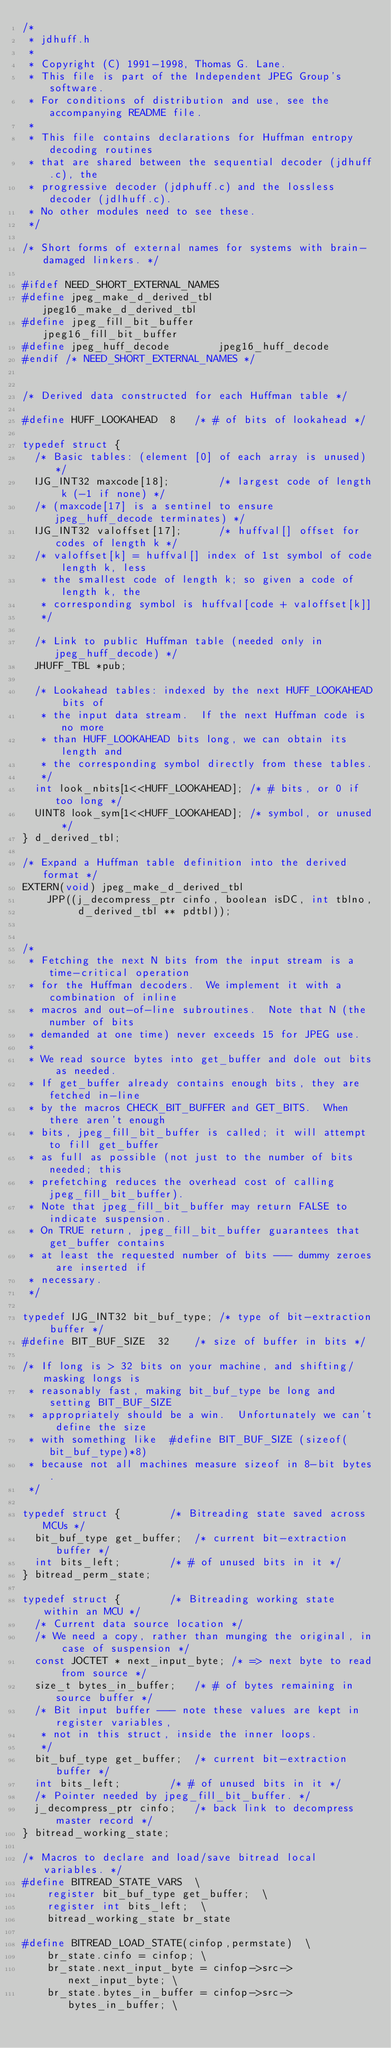<code> <loc_0><loc_0><loc_500><loc_500><_C_>/*
 * jdhuff.h
 *
 * Copyright (C) 1991-1998, Thomas G. Lane.
 * This file is part of the Independent JPEG Group's software.
 * For conditions of distribution and use, see the accompanying README file.
 *
 * This file contains declarations for Huffman entropy decoding routines
 * that are shared between the sequential decoder (jdhuff.c), the
 * progressive decoder (jdphuff.c) and the lossless decoder (jdlhuff.c).
 * No other modules need to see these.
 */

/* Short forms of external names for systems with brain-damaged linkers. */

#ifdef NEED_SHORT_EXTERNAL_NAMES
#define jpeg_make_d_derived_tbl		jpeg16_make_d_derived_tbl
#define jpeg_fill_bit_buffer		jpeg16_fill_bit_buffer
#define jpeg_huff_decode		jpeg16_huff_decode
#endif /* NEED_SHORT_EXTERNAL_NAMES */


/* Derived data constructed for each Huffman table */

#define HUFF_LOOKAHEAD	8	/* # of bits of lookahead */

typedef struct {
  /* Basic tables: (element [0] of each array is unused) */
  IJG_INT32 maxcode[18];		/* largest code of length k (-1 if none) */
  /* (maxcode[17] is a sentinel to ensure jpeg_huff_decode terminates) */
  IJG_INT32 valoffset[17];		/* huffval[] offset for codes of length k */
  /* valoffset[k] = huffval[] index of 1st symbol of code length k, less
   * the smallest code of length k; so given a code of length k, the
   * corresponding symbol is huffval[code + valoffset[k]]
   */

  /* Link to public Huffman table (needed only in jpeg_huff_decode) */
  JHUFF_TBL *pub;

  /* Lookahead tables: indexed by the next HUFF_LOOKAHEAD bits of
   * the input data stream.  If the next Huffman code is no more
   * than HUFF_LOOKAHEAD bits long, we can obtain its length and
   * the corresponding symbol directly from these tables.
   */
  int look_nbits[1<<HUFF_LOOKAHEAD]; /* # bits, or 0 if too long */
  UINT8 look_sym[1<<HUFF_LOOKAHEAD]; /* symbol, or unused */
} d_derived_tbl;

/* Expand a Huffman table definition into the derived format */
EXTERN(void) jpeg_make_d_derived_tbl
	JPP((j_decompress_ptr cinfo, boolean isDC, int tblno,
	     d_derived_tbl ** pdtbl));


/*
 * Fetching the next N bits from the input stream is a time-critical operation
 * for the Huffman decoders.  We implement it with a combination of inline
 * macros and out-of-line subroutines.  Note that N (the number of bits
 * demanded at one time) never exceeds 15 for JPEG use.
 *
 * We read source bytes into get_buffer and dole out bits as needed.
 * If get_buffer already contains enough bits, they are fetched in-line
 * by the macros CHECK_BIT_BUFFER and GET_BITS.  When there aren't enough
 * bits, jpeg_fill_bit_buffer is called; it will attempt to fill get_buffer
 * as full as possible (not just to the number of bits needed; this
 * prefetching reduces the overhead cost of calling jpeg_fill_bit_buffer).
 * Note that jpeg_fill_bit_buffer may return FALSE to indicate suspension.
 * On TRUE return, jpeg_fill_bit_buffer guarantees that get_buffer contains
 * at least the requested number of bits --- dummy zeroes are inserted if
 * necessary.
 */

typedef IJG_INT32 bit_buf_type;	/* type of bit-extraction buffer */
#define BIT_BUF_SIZE  32	/* size of buffer in bits */

/* If long is > 32 bits on your machine, and shifting/masking longs is
 * reasonably fast, making bit_buf_type be long and setting BIT_BUF_SIZE
 * appropriately should be a win.  Unfortunately we can't define the size
 * with something like  #define BIT_BUF_SIZE (sizeof(bit_buf_type)*8)
 * because not all machines measure sizeof in 8-bit bytes.
 */

typedef struct {		/* Bitreading state saved across MCUs */
  bit_buf_type get_buffer;	/* current bit-extraction buffer */
  int bits_left;		/* # of unused bits in it */
} bitread_perm_state;

typedef struct {		/* Bitreading working state within an MCU */
  /* Current data source location */
  /* We need a copy, rather than munging the original, in case of suspension */
  const JOCTET * next_input_byte; /* => next byte to read from source */
  size_t bytes_in_buffer;	/* # of bytes remaining in source buffer */
  /* Bit input buffer --- note these values are kept in register variables,
   * not in this struct, inside the inner loops.
   */
  bit_buf_type get_buffer;	/* current bit-extraction buffer */
  int bits_left;		/* # of unused bits in it */
  /* Pointer needed by jpeg_fill_bit_buffer. */
  j_decompress_ptr cinfo;	/* back link to decompress master record */
} bitread_working_state;

/* Macros to declare and load/save bitread local variables. */
#define BITREAD_STATE_VARS  \
	register bit_buf_type get_buffer;  \
	register int bits_left;  \
	bitread_working_state br_state

#define BITREAD_LOAD_STATE(cinfop,permstate)  \
	br_state.cinfo = cinfop; \
	br_state.next_input_byte = cinfop->src->next_input_byte; \
	br_state.bytes_in_buffer = cinfop->src->bytes_in_buffer; \</code> 